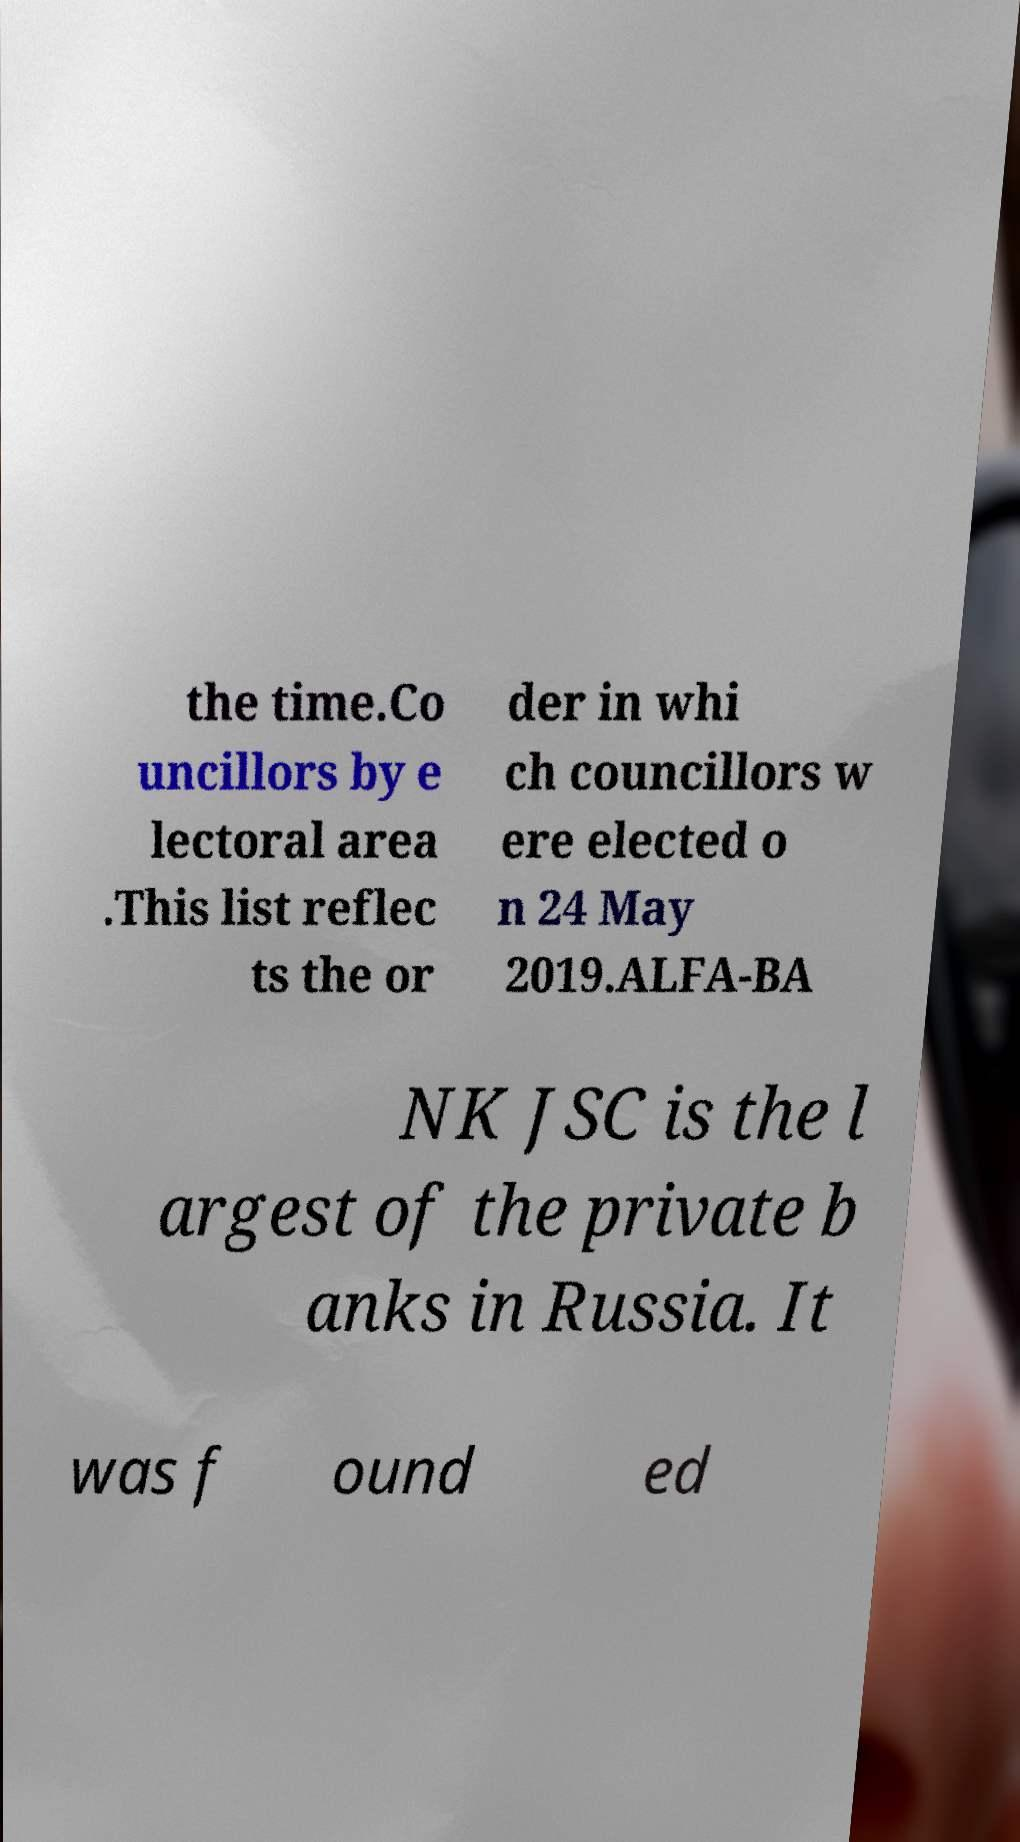For documentation purposes, I need the text within this image transcribed. Could you provide that? the time.Co uncillors by e lectoral area .This list reflec ts the or der in whi ch councillors w ere elected o n 24 May 2019.ALFA-BA NK JSC is the l argest of the private b anks in Russia. It was f ound ed 